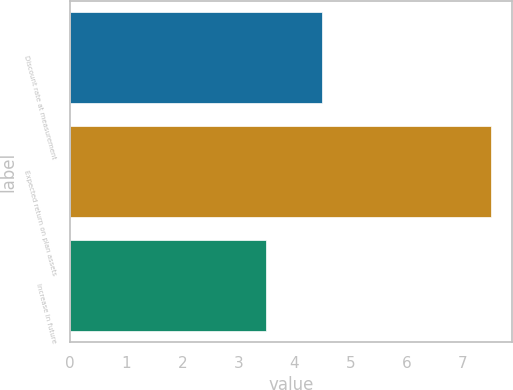Convert chart to OTSL. <chart><loc_0><loc_0><loc_500><loc_500><bar_chart><fcel>Discount rate at measurement<fcel>Expected return on plan assets<fcel>Increase in future<nl><fcel>4.5<fcel>7.5<fcel>3.5<nl></chart> 